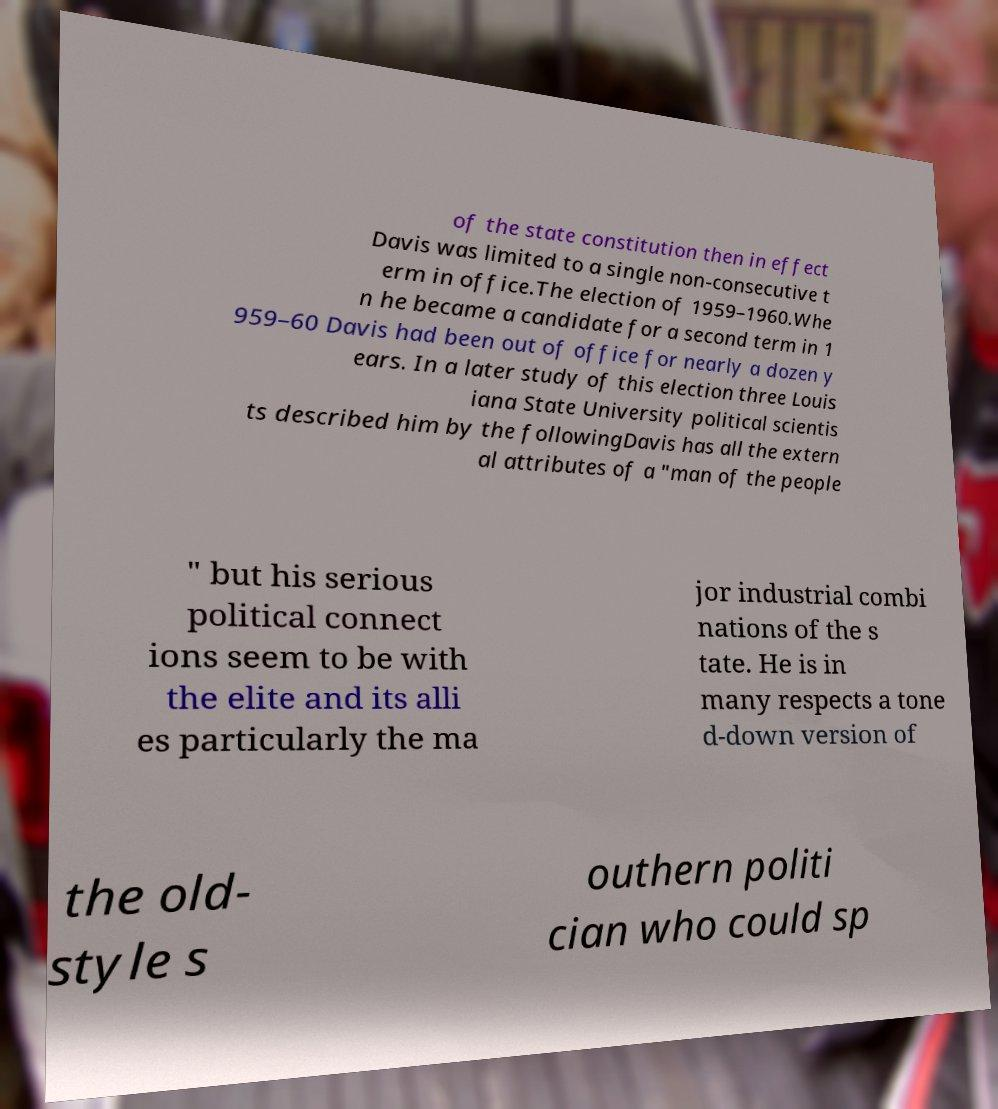Could you assist in decoding the text presented in this image and type it out clearly? of the state constitution then in effect Davis was limited to a single non-consecutive t erm in office.The election of 1959–1960.Whe n he became a candidate for a second term in 1 959–60 Davis had been out of office for nearly a dozen y ears. In a later study of this election three Louis iana State University political scientis ts described him by the followingDavis has all the extern al attributes of a "man of the people " but his serious political connect ions seem to be with the elite and its alli es particularly the ma jor industrial combi nations of the s tate. He is in many respects a tone d-down version of the old- style s outhern politi cian who could sp 